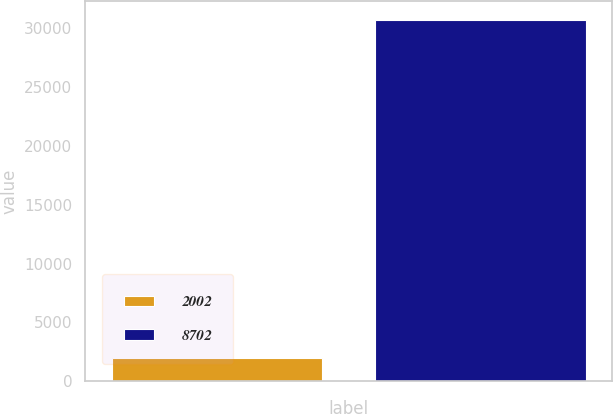Convert chart to OTSL. <chart><loc_0><loc_0><loc_500><loc_500><bar_chart><fcel>2002<fcel>8702<nl><fcel>2000<fcel>30719<nl></chart> 